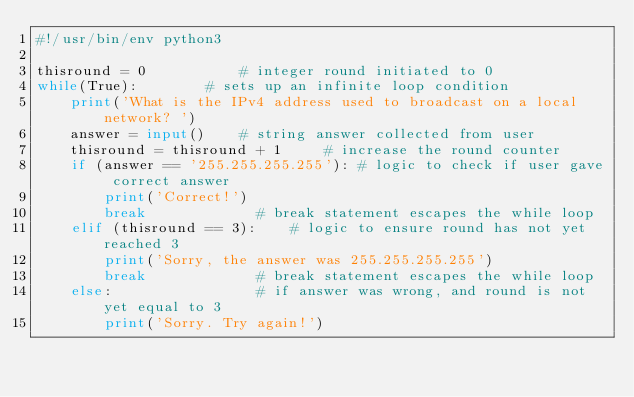Convert code to text. <code><loc_0><loc_0><loc_500><loc_500><_Python_>#!/usr/bin/env python3

thisround = 0           # integer round initiated to 0
while(True):        # sets up an infinite loop condition
    print('What is the IPv4 address used to broadcast on a local network? ')
    answer = input()    # string answer collected from user
    thisround = thisround + 1     # increase the round counter
    if (answer == '255.255.255.255'): # logic to check if user gave correct answer
        print('Correct!')
        break             # break statement escapes the while loop
    elif (thisround == 3):    # logic to ensure round has not yet reached 3
        print('Sorry, the answer was 255.255.255.255')
        break             # break statement escapes the while loop
    else:                 # if answer was wrong, and round is not yet equal to 3
        print('Sorry. Try again!')

</code> 